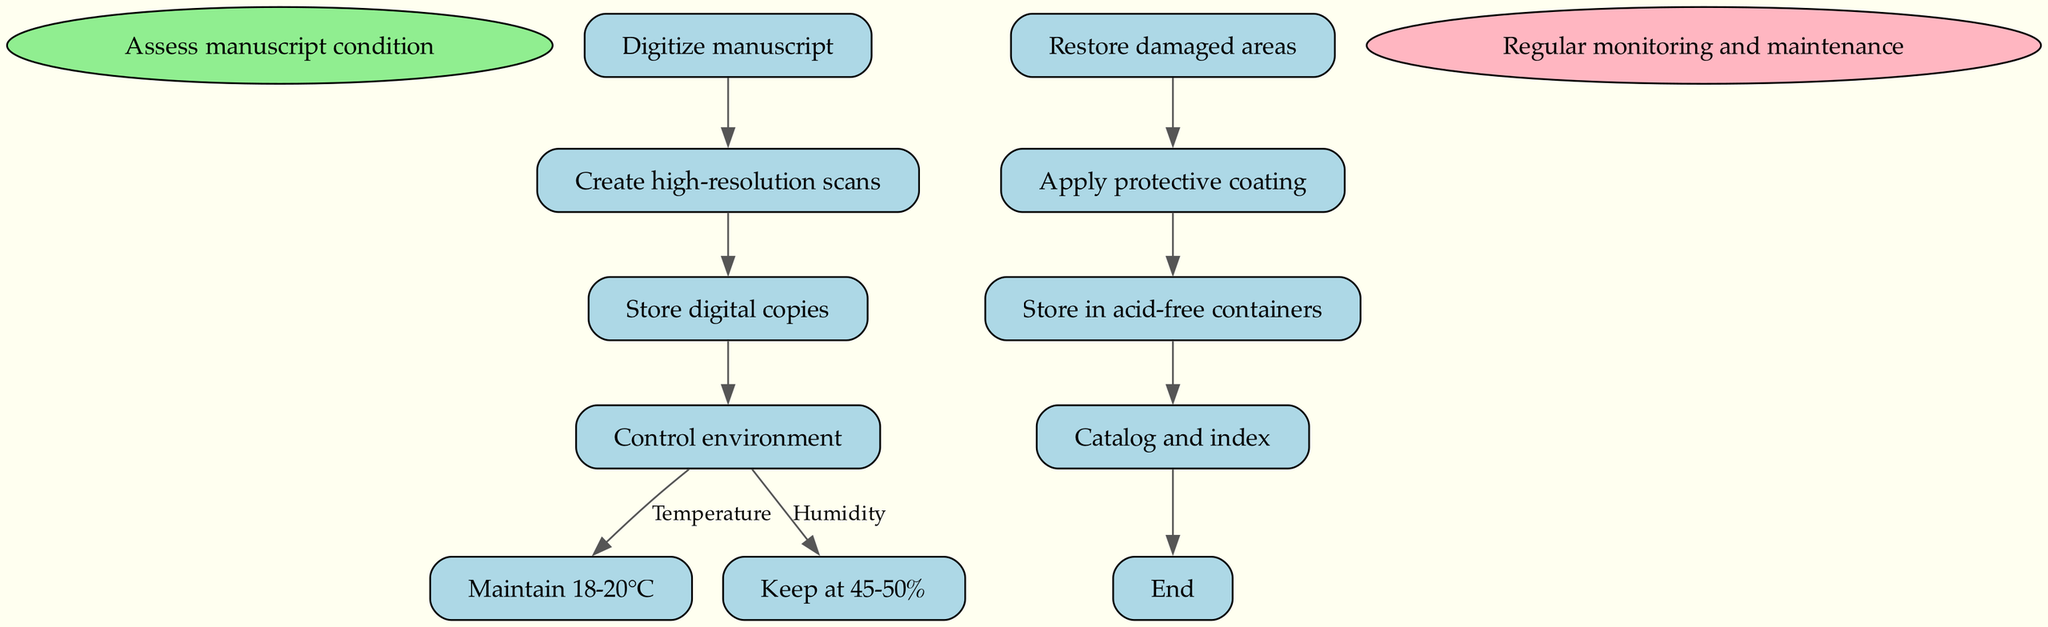What is the first step in preserving ancient Italian manuscripts? The first step according to the diagram is "Assess manuscript condition". This is the initial action that sets the process in motion for further preservation activities.
Answer: Assess manuscript condition How many steps are in the preservation process? The diagram contains a total of 8 distinct steps, excluding the start and end nodes. Each step represents a crucial action taken in the preservation of manuscripts.
Answer: 8 What is the temperature range recommended for controlling the environment? The recommended temperature range is specified as "18-20°C". This information can be found in the node that details the control environment step and its associated temperature edge.
Answer: 18-20°C What follows after digitizing the manuscript? After digitization, the next step outlined in the diagram is "Create high-resolution scans". This illustrates a sequential action that occurs as part of the overall manuscript preservation process.
Answer: Create high-resolution scans Which step comes before "Catalog and index"? The step that precedes "Catalog and index" is "Store in acid-free containers". This is deduced from following the flow of the diagram from the latter back to the prior node.
Answer: Store in acid-free containers What is applied after restoring damaged areas? After the "Restore damaged areas" step, the diagram indicates that "Apply protective coating" is the next action to take in the preservation process. This shows a direct flow from restoration to protection.
Answer: Apply protective coating What is the common goal of controlling temperature and humidity? The common goal is to "Control environment". This is a summary of the nodes specifically detailing the parameters for both temperature and humidity, showing their interrelated purpose in preservation.
Answer: Control environment What is the color of the start node? The start node is represented in light green, as indicated in the diagram which uses a specific color coding for different types of nodes.
Answer: Light green What action concludes the diagram? The final action listed in the diagram is "Regular monitoring and maintenance". This underscores the necessity of ongoing care even after the initial preservation steps are completed.
Answer: Regular monitoring and maintenance 